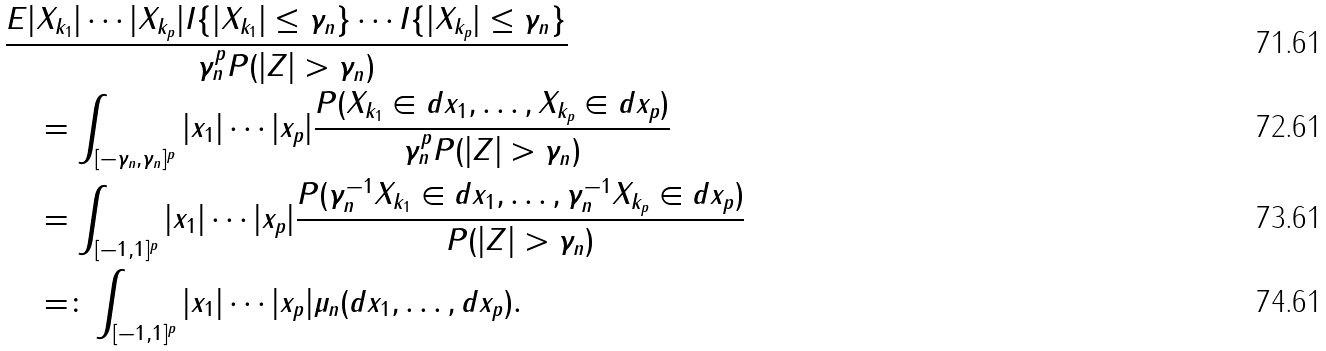<formula> <loc_0><loc_0><loc_500><loc_500>& \frac { E | X _ { k _ { 1 } } | \cdots | X _ { k _ { p } } | I \{ | X _ { k _ { 1 } } | \leq \gamma _ { n } \} \cdots I \{ | X _ { k _ { p } } | \leq \gamma _ { n } \} } { \gamma _ { n } ^ { p } P ( | Z | > \gamma _ { n } ) } \\ & \quad = \int _ { [ - \gamma _ { n } , \gamma _ { n } ] ^ { p } } | x _ { 1 } | \cdots | x _ { p } | \frac { P ( X _ { k _ { 1 } } \in d x _ { 1 } , \dots , X _ { k _ { p } } \in d x _ { p } ) } { \gamma _ { n } ^ { p } P ( | Z | > \gamma _ { n } ) } \\ & \quad = \int _ { [ - 1 , 1 ] ^ { p } } | x _ { 1 } | \cdots | x _ { p } | \frac { P ( \gamma _ { n } ^ { - 1 } X _ { k _ { 1 } } \in d x _ { 1 } , \dots , \gamma _ { n } ^ { - 1 } X _ { k _ { p } } \in d x _ { p } ) } { P ( | Z | > \gamma _ { n } ) } \\ & \quad = \colon \int _ { [ - 1 , 1 ] ^ { p } } | x _ { 1 } | \cdots | x _ { p } | \mu _ { n } ( d x _ { 1 } , \dots , d x _ { p } ) .</formula> 